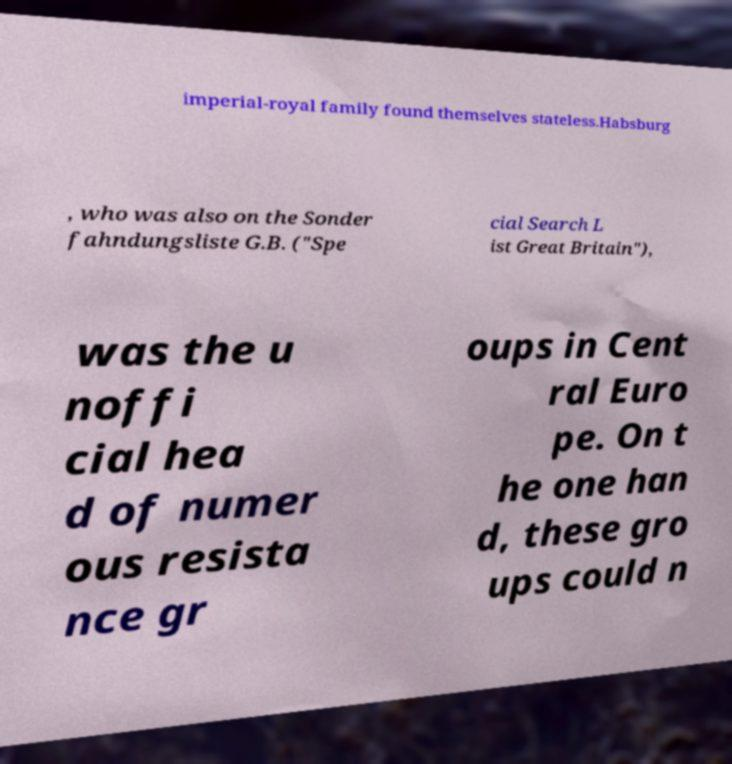Could you extract and type out the text from this image? imperial-royal family found themselves stateless.Habsburg , who was also on the Sonder fahndungsliste G.B. ("Spe cial Search L ist Great Britain"), was the u noffi cial hea d of numer ous resista nce gr oups in Cent ral Euro pe. On t he one han d, these gro ups could n 